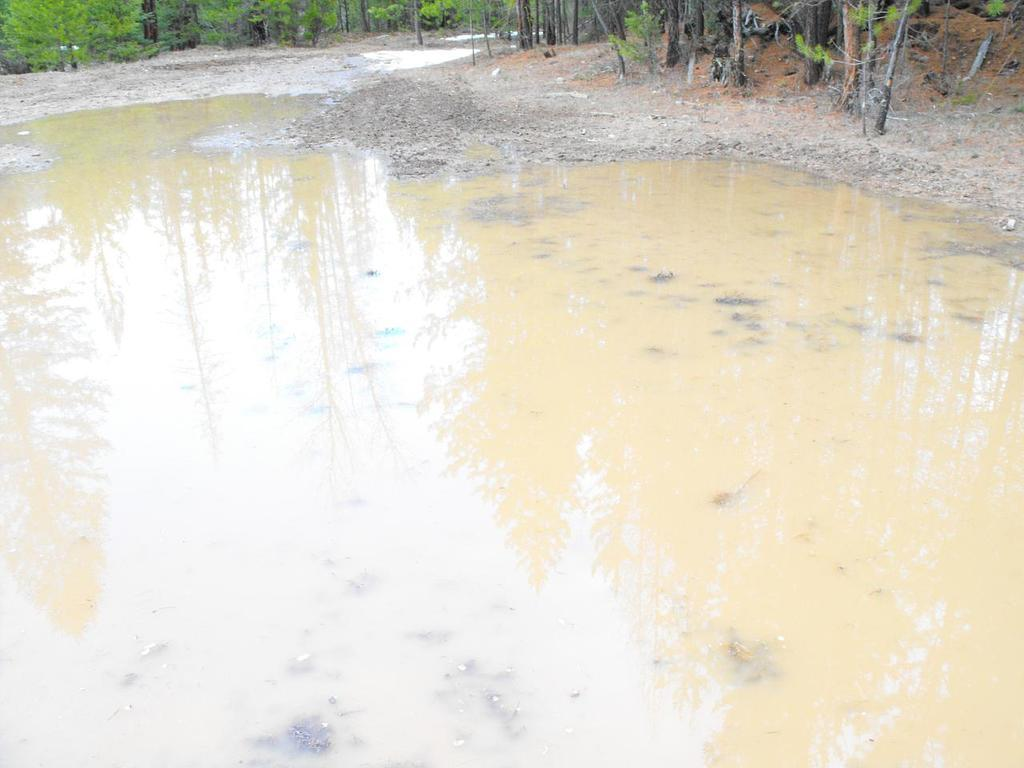What is visible on the ground in the image? There is a road visible in the image. What is present on the road in the image? There is water on the road. What can be seen in the background of the image? There are many trees in the background of the image. How does the drain help manage the water on the road in the image? There is no drain present in the image; it only shows a road with water on it. What type of clam can be seen crawling on the road in the image? There are no clams present in the image; it only shows a road with water on it. 